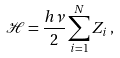<formula> <loc_0><loc_0><loc_500><loc_500>\mathcal { H } = \frac { h \nu } { 2 } \sum _ { i = 1 } ^ { N } Z _ { i } \, ,</formula> 